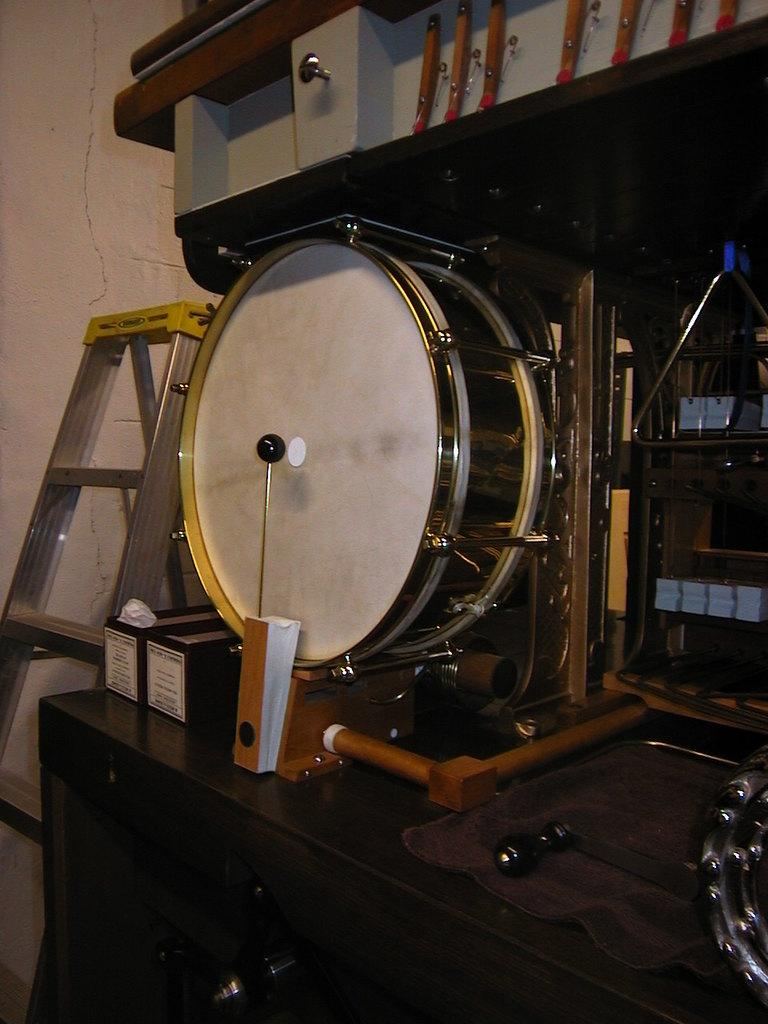What color is the table in the image? The table in the image is black. What is on top of the table? There is a musical instrument and other objects on the table. Can you describe the background of the image? There is a ladder and a wall in the background of the image. What type of bone can be seen on the table in the image? There is no bone present on the table in the image. 